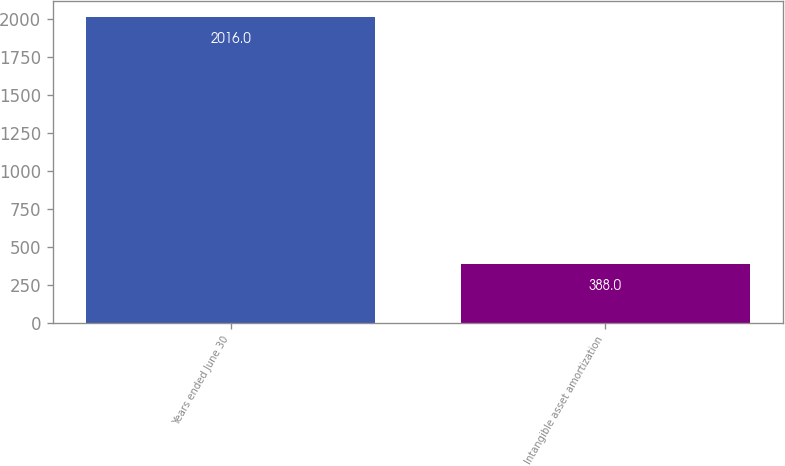Convert chart to OTSL. <chart><loc_0><loc_0><loc_500><loc_500><bar_chart><fcel>Years ended June 30<fcel>Intangible asset amortization<nl><fcel>2016<fcel>388<nl></chart> 